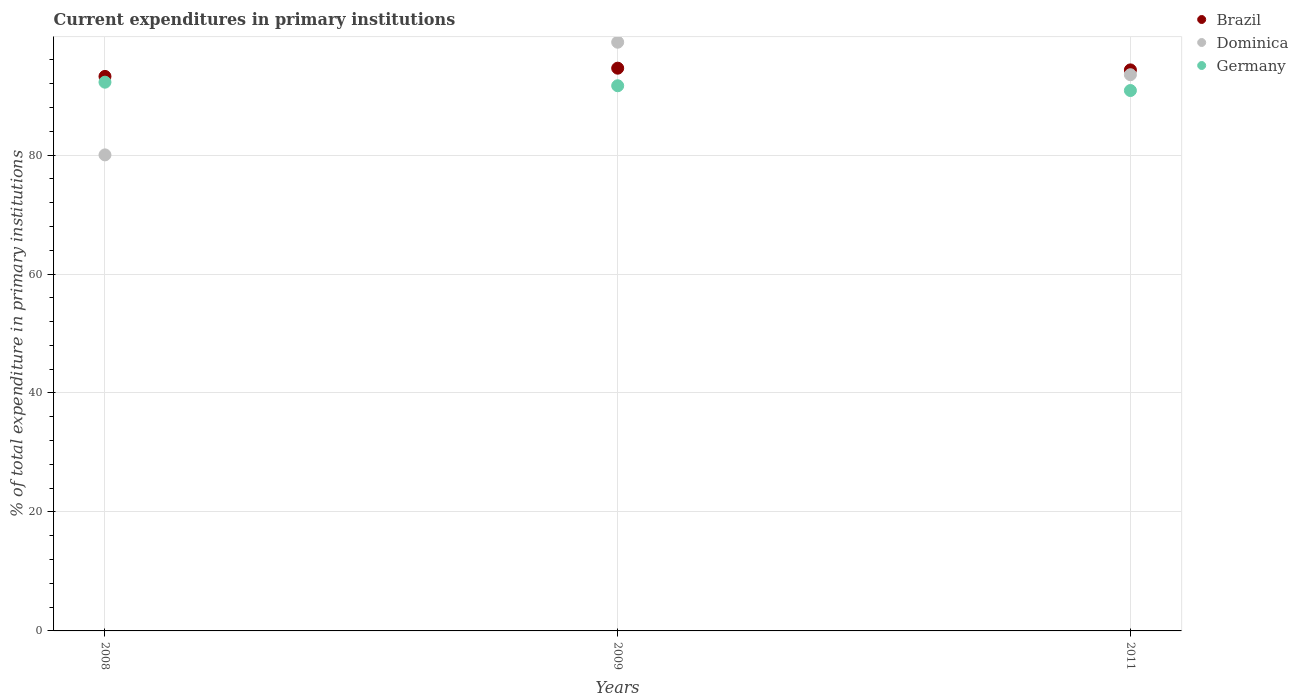What is the current expenditures in primary institutions in Germany in 2011?
Keep it short and to the point. 90.85. Across all years, what is the maximum current expenditures in primary institutions in Brazil?
Offer a very short reply. 94.6. Across all years, what is the minimum current expenditures in primary institutions in Germany?
Give a very brief answer. 90.85. What is the total current expenditures in primary institutions in Dominica in the graph?
Your answer should be compact. 272.5. What is the difference between the current expenditures in primary institutions in Germany in 2008 and that in 2009?
Your response must be concise. 0.6. What is the difference between the current expenditures in primary institutions in Dominica in 2009 and the current expenditures in primary institutions in Germany in 2008?
Provide a short and direct response. 6.72. What is the average current expenditures in primary institutions in Dominica per year?
Provide a short and direct response. 90.83. In the year 2008, what is the difference between the current expenditures in primary institutions in Dominica and current expenditures in primary institutions in Germany?
Keep it short and to the point. -12.22. In how many years, is the current expenditures in primary institutions in Germany greater than 4 %?
Offer a terse response. 3. What is the ratio of the current expenditures in primary institutions in Dominica in 2009 to that in 2011?
Your answer should be very brief. 1.06. Is the current expenditures in primary institutions in Germany in 2008 less than that in 2011?
Keep it short and to the point. No. Is the difference between the current expenditures in primary institutions in Dominica in 2008 and 2011 greater than the difference between the current expenditures in primary institutions in Germany in 2008 and 2011?
Your answer should be very brief. No. What is the difference between the highest and the second highest current expenditures in primary institutions in Dominica?
Your response must be concise. 5.47. What is the difference between the highest and the lowest current expenditures in primary institutions in Brazil?
Make the answer very short. 1.38. In how many years, is the current expenditures in primary institutions in Brazil greater than the average current expenditures in primary institutions in Brazil taken over all years?
Your answer should be compact. 2. Is it the case that in every year, the sum of the current expenditures in primary institutions in Brazil and current expenditures in primary institutions in Dominica  is greater than the current expenditures in primary institutions in Germany?
Keep it short and to the point. Yes. Does the current expenditures in primary institutions in Brazil monotonically increase over the years?
Your answer should be very brief. No. Is the current expenditures in primary institutions in Brazil strictly greater than the current expenditures in primary institutions in Dominica over the years?
Make the answer very short. No. Is the current expenditures in primary institutions in Brazil strictly less than the current expenditures in primary institutions in Germany over the years?
Your response must be concise. No. Are the values on the major ticks of Y-axis written in scientific E-notation?
Provide a succinct answer. No. Does the graph contain grids?
Provide a short and direct response. Yes. Where does the legend appear in the graph?
Provide a succinct answer. Top right. How are the legend labels stacked?
Ensure brevity in your answer.  Vertical. What is the title of the graph?
Your response must be concise. Current expenditures in primary institutions. Does "Maldives" appear as one of the legend labels in the graph?
Keep it short and to the point. No. What is the label or title of the X-axis?
Offer a very short reply. Years. What is the label or title of the Y-axis?
Give a very brief answer. % of total expenditure in primary institutions. What is the % of total expenditure in primary institutions of Brazil in 2008?
Keep it short and to the point. 93.22. What is the % of total expenditure in primary institutions of Dominica in 2008?
Offer a very short reply. 80.03. What is the % of total expenditure in primary institutions in Germany in 2008?
Your answer should be very brief. 92.25. What is the % of total expenditure in primary institutions of Brazil in 2009?
Offer a terse response. 94.6. What is the % of total expenditure in primary institutions of Dominica in 2009?
Provide a short and direct response. 98.97. What is the % of total expenditure in primary institutions in Germany in 2009?
Ensure brevity in your answer.  91.65. What is the % of total expenditure in primary institutions of Brazil in 2011?
Keep it short and to the point. 94.32. What is the % of total expenditure in primary institutions of Dominica in 2011?
Give a very brief answer. 93.5. What is the % of total expenditure in primary institutions of Germany in 2011?
Give a very brief answer. 90.85. Across all years, what is the maximum % of total expenditure in primary institutions in Brazil?
Keep it short and to the point. 94.6. Across all years, what is the maximum % of total expenditure in primary institutions in Dominica?
Provide a short and direct response. 98.97. Across all years, what is the maximum % of total expenditure in primary institutions of Germany?
Provide a succinct answer. 92.25. Across all years, what is the minimum % of total expenditure in primary institutions of Brazil?
Provide a short and direct response. 93.22. Across all years, what is the minimum % of total expenditure in primary institutions in Dominica?
Give a very brief answer. 80.03. Across all years, what is the minimum % of total expenditure in primary institutions of Germany?
Offer a terse response. 90.85. What is the total % of total expenditure in primary institutions of Brazil in the graph?
Offer a terse response. 282.14. What is the total % of total expenditure in primary institutions of Dominica in the graph?
Your answer should be compact. 272.5. What is the total % of total expenditure in primary institutions in Germany in the graph?
Offer a terse response. 274.75. What is the difference between the % of total expenditure in primary institutions in Brazil in 2008 and that in 2009?
Ensure brevity in your answer.  -1.38. What is the difference between the % of total expenditure in primary institutions of Dominica in 2008 and that in 2009?
Your answer should be compact. -18.94. What is the difference between the % of total expenditure in primary institutions of Germany in 2008 and that in 2009?
Make the answer very short. 0.6. What is the difference between the % of total expenditure in primary institutions of Brazil in 2008 and that in 2011?
Make the answer very short. -1.1. What is the difference between the % of total expenditure in primary institutions of Dominica in 2008 and that in 2011?
Offer a terse response. -13.48. What is the difference between the % of total expenditure in primary institutions in Germany in 2008 and that in 2011?
Give a very brief answer. 1.4. What is the difference between the % of total expenditure in primary institutions in Brazil in 2009 and that in 2011?
Offer a very short reply. 0.29. What is the difference between the % of total expenditure in primary institutions in Dominica in 2009 and that in 2011?
Your response must be concise. 5.47. What is the difference between the % of total expenditure in primary institutions of Germany in 2009 and that in 2011?
Give a very brief answer. 0.8. What is the difference between the % of total expenditure in primary institutions in Brazil in 2008 and the % of total expenditure in primary institutions in Dominica in 2009?
Your answer should be compact. -5.75. What is the difference between the % of total expenditure in primary institutions of Brazil in 2008 and the % of total expenditure in primary institutions of Germany in 2009?
Offer a very short reply. 1.57. What is the difference between the % of total expenditure in primary institutions in Dominica in 2008 and the % of total expenditure in primary institutions in Germany in 2009?
Provide a short and direct response. -11.62. What is the difference between the % of total expenditure in primary institutions of Brazil in 2008 and the % of total expenditure in primary institutions of Dominica in 2011?
Your response must be concise. -0.28. What is the difference between the % of total expenditure in primary institutions of Brazil in 2008 and the % of total expenditure in primary institutions of Germany in 2011?
Your answer should be very brief. 2.37. What is the difference between the % of total expenditure in primary institutions of Dominica in 2008 and the % of total expenditure in primary institutions of Germany in 2011?
Keep it short and to the point. -10.82. What is the difference between the % of total expenditure in primary institutions of Brazil in 2009 and the % of total expenditure in primary institutions of Dominica in 2011?
Your response must be concise. 1.1. What is the difference between the % of total expenditure in primary institutions in Brazil in 2009 and the % of total expenditure in primary institutions in Germany in 2011?
Provide a short and direct response. 3.76. What is the difference between the % of total expenditure in primary institutions in Dominica in 2009 and the % of total expenditure in primary institutions in Germany in 2011?
Provide a succinct answer. 8.12. What is the average % of total expenditure in primary institutions of Brazil per year?
Your answer should be very brief. 94.05. What is the average % of total expenditure in primary institutions in Dominica per year?
Your response must be concise. 90.83. What is the average % of total expenditure in primary institutions of Germany per year?
Provide a succinct answer. 91.58. In the year 2008, what is the difference between the % of total expenditure in primary institutions in Brazil and % of total expenditure in primary institutions in Dominica?
Provide a succinct answer. 13.19. In the year 2008, what is the difference between the % of total expenditure in primary institutions in Brazil and % of total expenditure in primary institutions in Germany?
Offer a terse response. 0.97. In the year 2008, what is the difference between the % of total expenditure in primary institutions of Dominica and % of total expenditure in primary institutions of Germany?
Provide a short and direct response. -12.22. In the year 2009, what is the difference between the % of total expenditure in primary institutions of Brazil and % of total expenditure in primary institutions of Dominica?
Your answer should be compact. -4.37. In the year 2009, what is the difference between the % of total expenditure in primary institutions in Brazil and % of total expenditure in primary institutions in Germany?
Offer a very short reply. 2.95. In the year 2009, what is the difference between the % of total expenditure in primary institutions in Dominica and % of total expenditure in primary institutions in Germany?
Your answer should be compact. 7.32. In the year 2011, what is the difference between the % of total expenditure in primary institutions in Brazil and % of total expenditure in primary institutions in Dominica?
Your answer should be very brief. 0.81. In the year 2011, what is the difference between the % of total expenditure in primary institutions of Brazil and % of total expenditure in primary institutions of Germany?
Your answer should be compact. 3.47. In the year 2011, what is the difference between the % of total expenditure in primary institutions of Dominica and % of total expenditure in primary institutions of Germany?
Your answer should be compact. 2.66. What is the ratio of the % of total expenditure in primary institutions of Brazil in 2008 to that in 2009?
Provide a succinct answer. 0.99. What is the ratio of the % of total expenditure in primary institutions of Dominica in 2008 to that in 2009?
Your response must be concise. 0.81. What is the ratio of the % of total expenditure in primary institutions in Germany in 2008 to that in 2009?
Offer a very short reply. 1.01. What is the ratio of the % of total expenditure in primary institutions in Brazil in 2008 to that in 2011?
Make the answer very short. 0.99. What is the ratio of the % of total expenditure in primary institutions of Dominica in 2008 to that in 2011?
Offer a terse response. 0.86. What is the ratio of the % of total expenditure in primary institutions in Germany in 2008 to that in 2011?
Give a very brief answer. 1.02. What is the ratio of the % of total expenditure in primary institutions of Brazil in 2009 to that in 2011?
Offer a very short reply. 1. What is the ratio of the % of total expenditure in primary institutions in Dominica in 2009 to that in 2011?
Your response must be concise. 1.06. What is the ratio of the % of total expenditure in primary institutions in Germany in 2009 to that in 2011?
Your answer should be very brief. 1.01. What is the difference between the highest and the second highest % of total expenditure in primary institutions in Brazil?
Your answer should be very brief. 0.29. What is the difference between the highest and the second highest % of total expenditure in primary institutions in Dominica?
Ensure brevity in your answer.  5.47. What is the difference between the highest and the second highest % of total expenditure in primary institutions of Germany?
Your answer should be very brief. 0.6. What is the difference between the highest and the lowest % of total expenditure in primary institutions in Brazil?
Make the answer very short. 1.38. What is the difference between the highest and the lowest % of total expenditure in primary institutions in Dominica?
Your response must be concise. 18.94. What is the difference between the highest and the lowest % of total expenditure in primary institutions in Germany?
Your answer should be very brief. 1.4. 